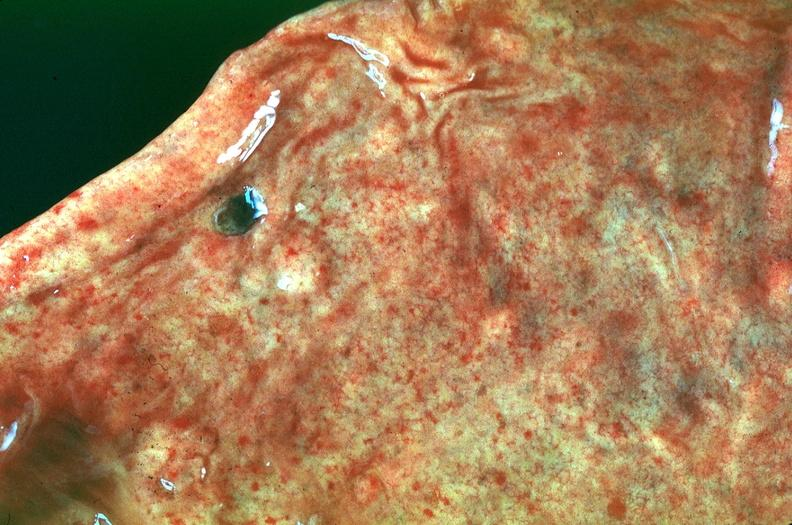s gastrointestinal present?
Answer the question using a single word or phrase. Yes 